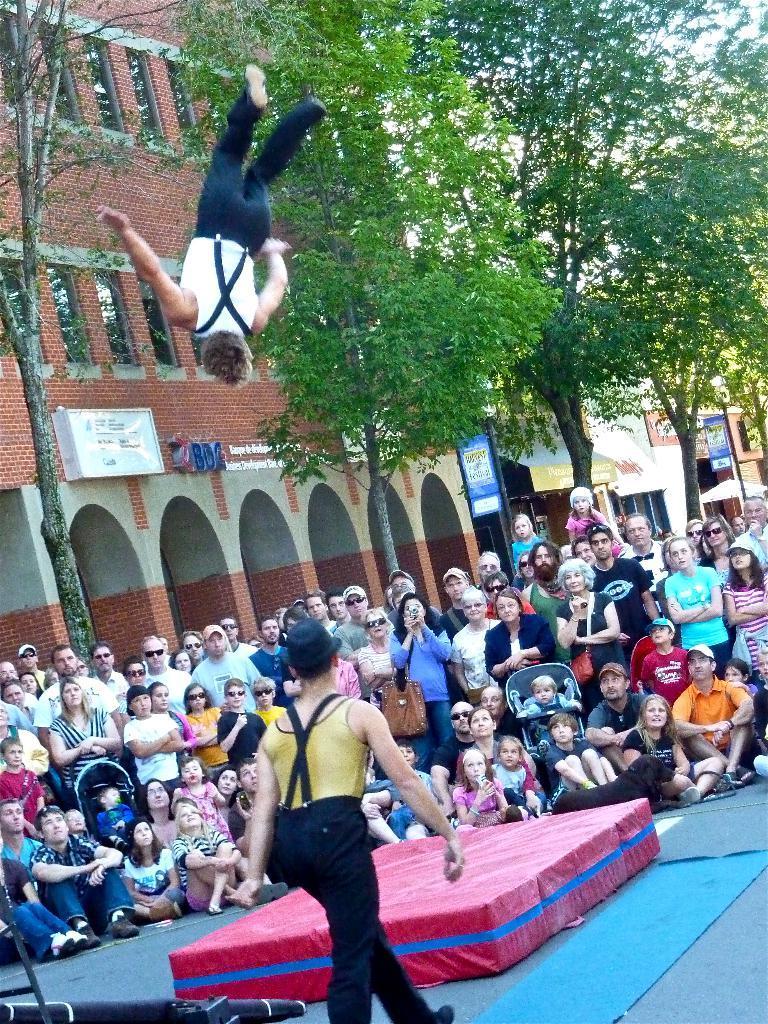How would you summarize this image in a sentence or two? In this image we can see a person flipping in air. At the bottom of the image there is a red color foam bed. There is a person walking. In the background of the image there are people, trees, buildings, boards with some text. 